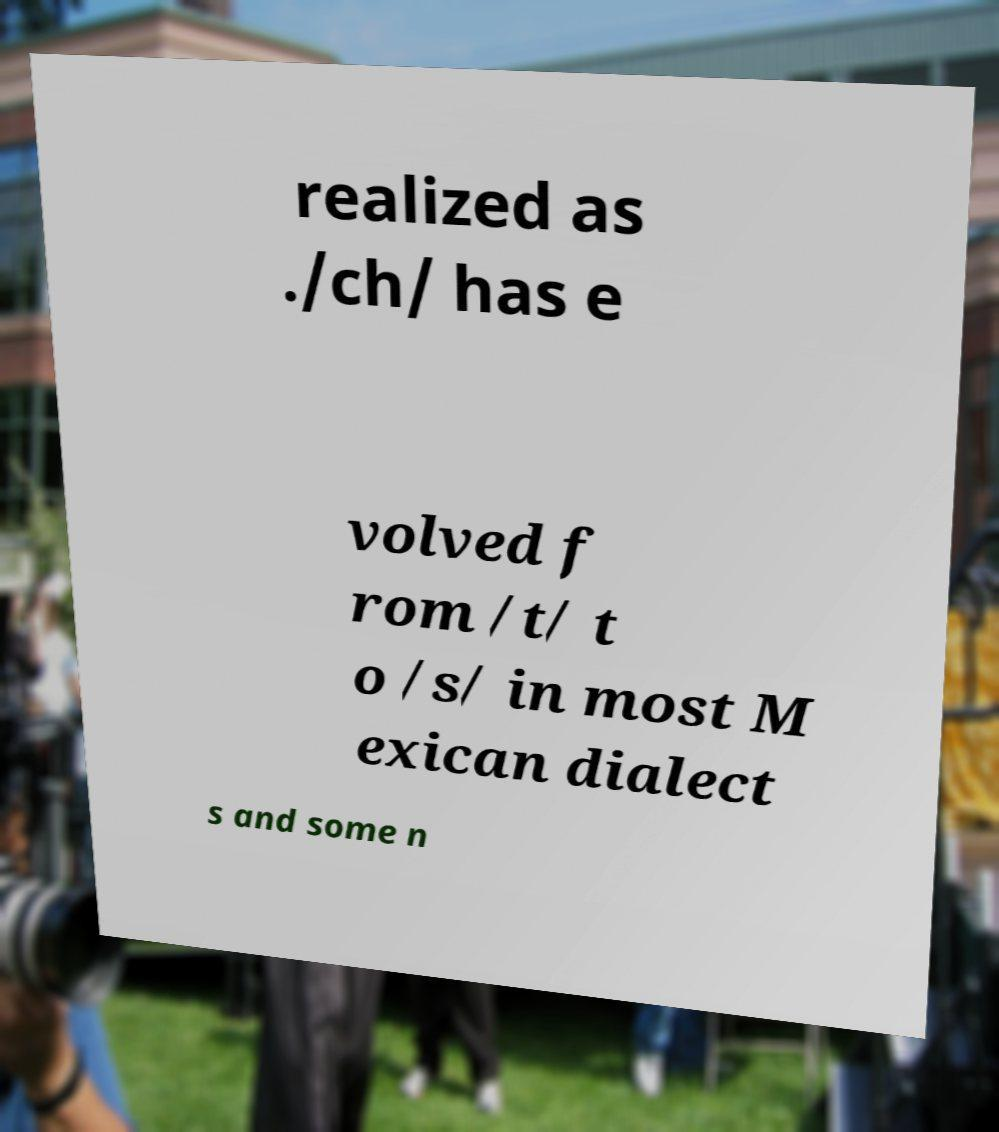What messages or text are displayed in this image? I need them in a readable, typed format. realized as ./ch/ has e volved f rom /t/ t o /s/ in most M exican dialect s and some n 